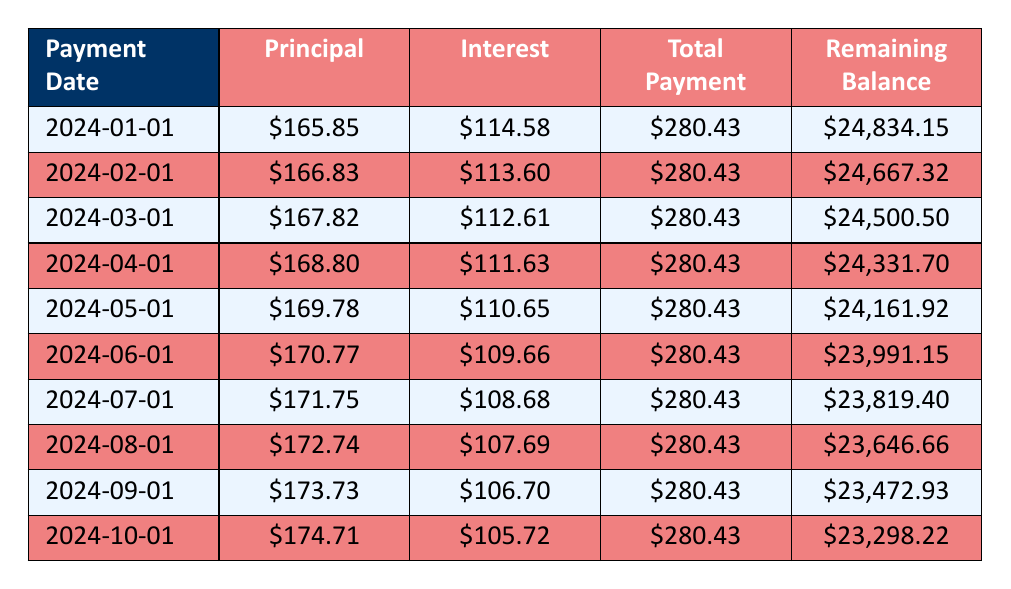What is the total monthly payment for the loan? The monthly payment amount is specified as 263.85 in the loan details.
Answer: 263.85 What is the interest payment for the third payment? The table shows the interest payment for the third payment number (3) is 112.61.
Answer: 112.61 How much principal is paid off after the fifth payment? The principal payments for each payment from 1 to 5 are as follows: 165.85, 166.83, 167.82, 168.80, and 169.78. Summing these gives 165.85 + 166.83 + 167.82 + 168.80 + 169.78 = 839.08.
Answer: 839.08 Is the interest payment for the first payment higher than for the second payment? Comparing the interest payments, the first payment is 114.58 and the second payment is 113.60. Since 114.58 is greater than 113.60, the statement is true.
Answer: Yes What is the remaining balance after the seventh payment? The remaining balance after the seventh payment is listed in the table as 23819.40.
Answer: 23819.40 What is the total amount of principal paid after the first 10 payments? Adding the principal payments from each of the first 10 payments yields: 165.85 + 166.83 + 167.82 + 168.80 + 169.78 + 170.77 + 171.75 + 172.74 + 173.73 + 174.71 = 1,674.05.
Answer: 1674.05 Is the remaining balance at the end of the tenth payment less than the original loan amount? The original loan amount is 25000, and the remaining balance after the tenth payment is 23298.22. Since 23298.22 is less than 25000, the statement is true.
Answer: Yes What is the average monthly principal payment over the first 10 payments? To find the average principal payment, you sum the principal payments for the first 10 payments and divide by 10. The total is 1,674.05, so the average is 1,674.05 / 10 = 167.405.
Answer: 167.41 How much does the interest payment decrease from the first payment to the tenth payment? The decrease in the interest payment is calculated as 114.58 (first payment) - 105.72 (tenth payment) = 8.86.
Answer: 8.86 